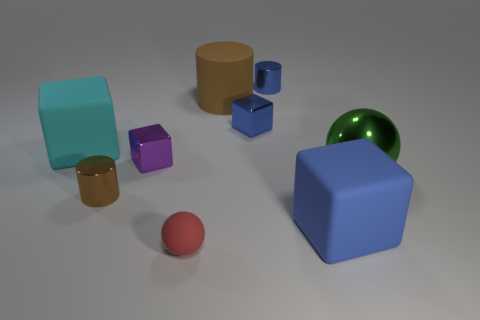What number of things are either rubber spheres or big green objects?
Provide a short and direct response. 2. What size is the other cylinder that is the same color as the matte cylinder?
Offer a very short reply. Small. Are there fewer big blocks than tiny gray shiny cylinders?
Your answer should be compact. No. There is a green thing that is made of the same material as the tiny brown object; what is its size?
Make the answer very short. Large. How big is the red matte object?
Make the answer very short. Small. There is a big metal object; what shape is it?
Your response must be concise. Sphere. There is a tiny metallic object that is in front of the large green metal sphere; does it have the same color as the big metallic thing?
Ensure brevity in your answer.  No. The other shiny object that is the same shape as the tiny purple object is what size?
Ensure brevity in your answer.  Small. Are there any other things that have the same material as the green thing?
Offer a very short reply. Yes. Is there a thing that is behind the matte thing behind the matte cube that is left of the red thing?
Make the answer very short. Yes. 